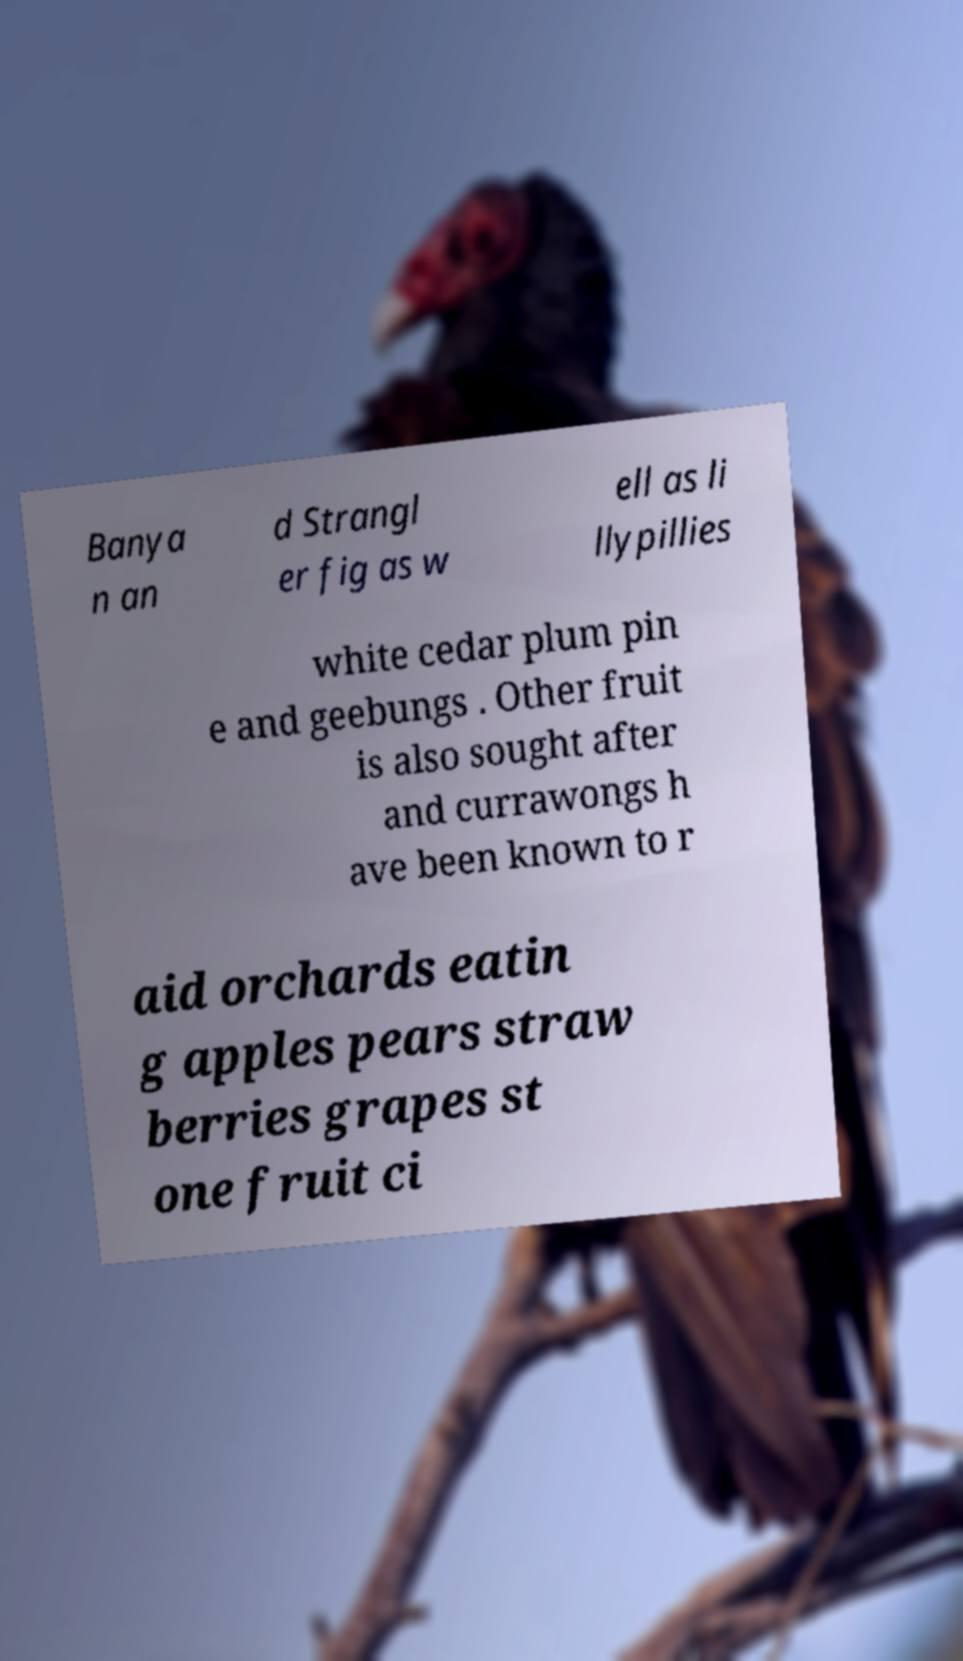What messages or text are displayed in this image? I need them in a readable, typed format. Banya n an d Strangl er fig as w ell as li llypillies white cedar plum pin e and geebungs . Other fruit is also sought after and currawongs h ave been known to r aid orchards eatin g apples pears straw berries grapes st one fruit ci 